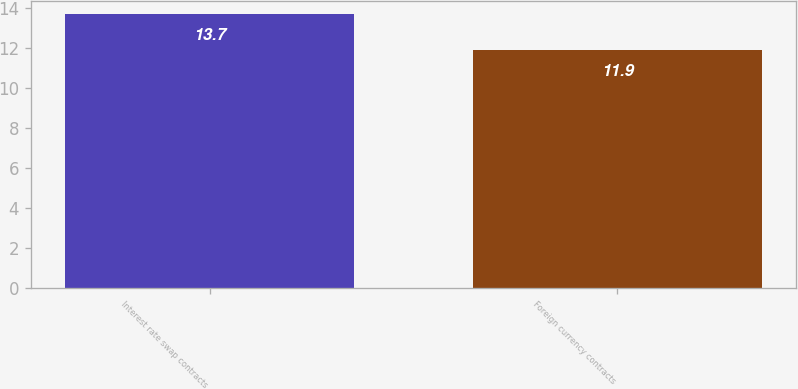Convert chart. <chart><loc_0><loc_0><loc_500><loc_500><bar_chart><fcel>Interest rate swap contracts<fcel>Foreign currency contracts<nl><fcel>13.7<fcel>11.9<nl></chart> 